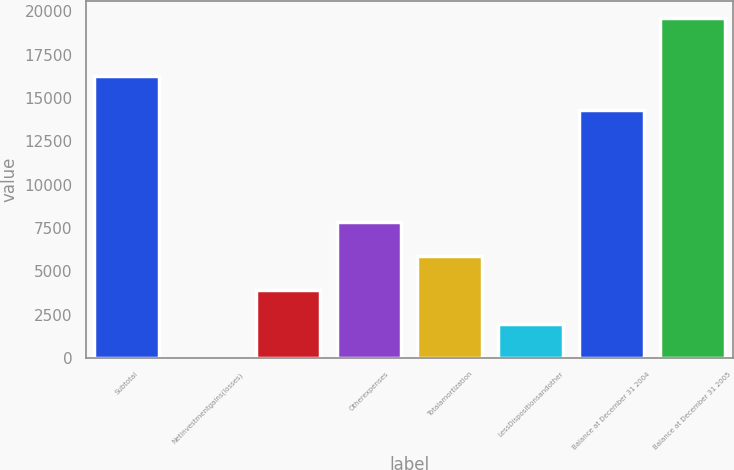Convert chart. <chart><loc_0><loc_0><loc_500><loc_500><bar_chart><fcel>Subtotal<fcel>Netinvestmentgains(losses)<fcel>Unnamed: 2<fcel>Otherexpenses<fcel>Totalamortization<fcel>LessDispositionsandother<fcel>Balance at December 31 2004<fcel>Balance at December 31 2005<nl><fcel>16290<fcel>11<fcel>3937<fcel>7863<fcel>5900<fcel>1974<fcel>14327<fcel>19641<nl></chart> 